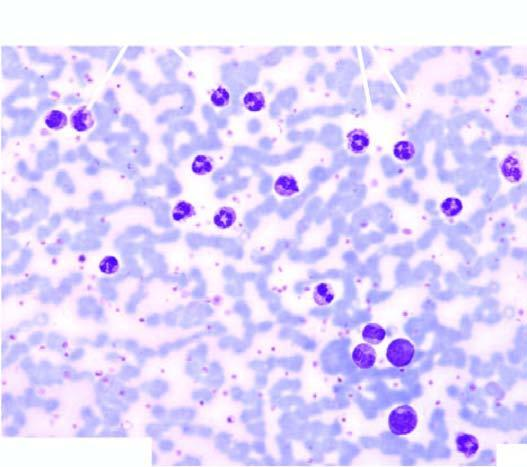what is higher as demonstrated by this cytochemical stain?
Answer the question using a single word or phrase. Neutrophil (or leucocyte) alkaline phosphatase (nap or lap) activity 